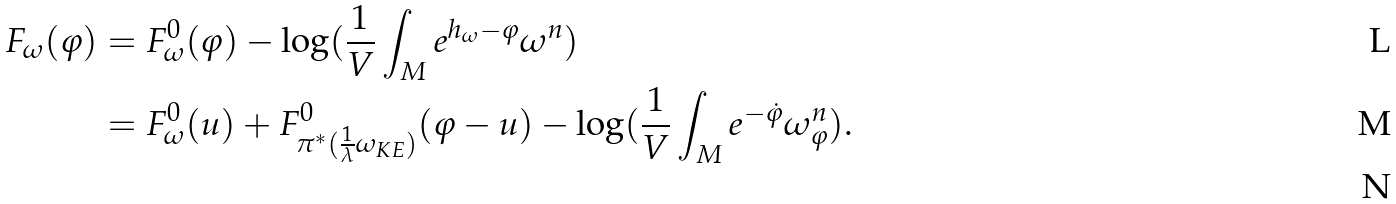Convert formula to latex. <formula><loc_0><loc_0><loc_500><loc_500>F _ { \omega } ( \varphi ) & = F _ { \omega } ^ { 0 } ( \varphi ) - \log ( \frac { 1 } { V } \int _ { M } e ^ { h _ { \omega } - \varphi } \omega ^ { n } ) \\ & = F _ { \omega } ^ { 0 } ( u ) + F _ { \pi ^ { * } ( \frac { 1 } { \lambda } \omega _ { K E } ) } ^ { 0 } ( \varphi - u ) - \log ( \frac { 1 } { V } \int _ { M } e ^ { - \dot { \varphi } } \omega _ { \varphi } ^ { n } ) . \\</formula> 